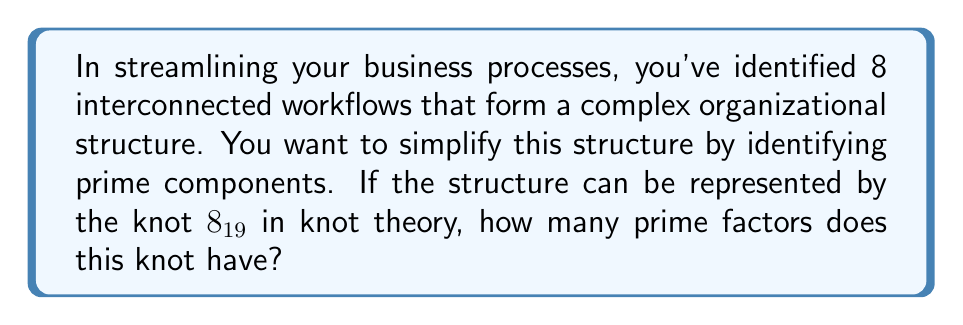Provide a solution to this math problem. To solve this problem, we need to follow these steps:

1) First, let's recall what $8_{19}$ means in knot theory:
   - The number 8 indicates that this is a knot with 8 crossings.
   - The subscript 19 is its position in the standard knot tables.

2) In knot theory, prime knots are knots that cannot be decomposed into simpler knots. They are the building blocks of more complex knots, similar to prime numbers in arithmetic.

3) The knot $8_{19}$ is known to be a composite knot. This means it can be decomposed into simpler knots.

4) The prime factorization of $8_{19}$ is:

   $$8_{19} = 3_1 \# 3_1 \# 3_1$$

   Where $3_1$ represents the trefoil knot and $\#$ denotes the knot sum operation.

5) Counting the factors in this decomposition, we see that $8_{19}$ is composed of three prime factors, all of which are trefoil knots.

6) Therefore, the number of prime factors of the knot $8_{19}$ is 3.

In the context of your business, this suggests that your complex structure of 8 interconnected workflows can be simplified into 3 fundamental processes, each analogous to a trefoil knot in complexity.
Answer: 3 